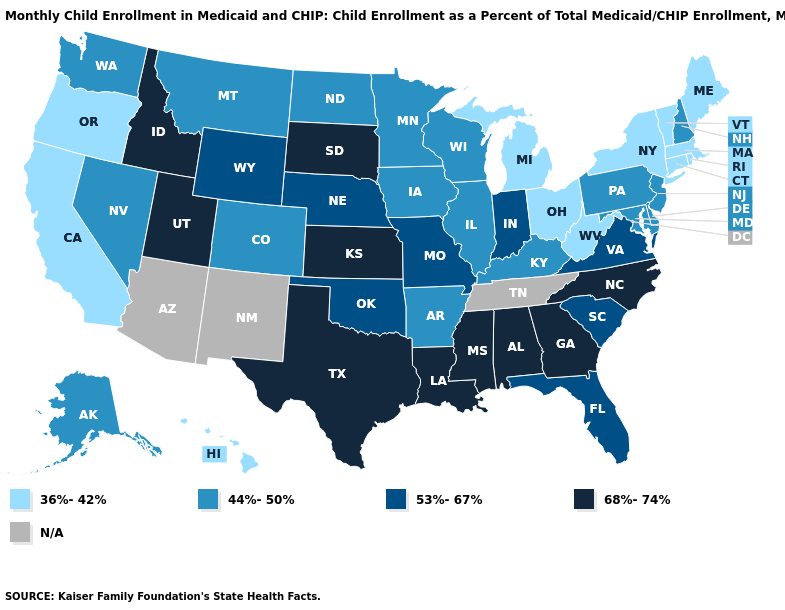Name the states that have a value in the range 36%-42%?
Answer briefly. California, Connecticut, Hawaii, Maine, Massachusetts, Michigan, New York, Ohio, Oregon, Rhode Island, Vermont, West Virginia. Does New York have the highest value in the Northeast?
Concise answer only. No. Among the states that border Louisiana , does Mississippi have the highest value?
Concise answer only. Yes. What is the lowest value in the West?
Write a very short answer. 36%-42%. What is the highest value in states that border Florida?
Answer briefly. 68%-74%. Name the states that have a value in the range 44%-50%?
Short answer required. Alaska, Arkansas, Colorado, Delaware, Illinois, Iowa, Kentucky, Maryland, Minnesota, Montana, Nevada, New Hampshire, New Jersey, North Dakota, Pennsylvania, Washington, Wisconsin. Does the first symbol in the legend represent the smallest category?
Short answer required. Yes. Name the states that have a value in the range 68%-74%?
Keep it brief. Alabama, Georgia, Idaho, Kansas, Louisiana, Mississippi, North Carolina, South Dakota, Texas, Utah. What is the highest value in the Northeast ?
Give a very brief answer. 44%-50%. Name the states that have a value in the range 36%-42%?
Be succinct. California, Connecticut, Hawaii, Maine, Massachusetts, Michigan, New York, Ohio, Oregon, Rhode Island, Vermont, West Virginia. Does Arkansas have the lowest value in the USA?
Give a very brief answer. No. What is the value of Michigan?
Answer briefly. 36%-42%. Which states have the highest value in the USA?
Quick response, please. Alabama, Georgia, Idaho, Kansas, Louisiana, Mississippi, North Carolina, South Dakota, Texas, Utah. 